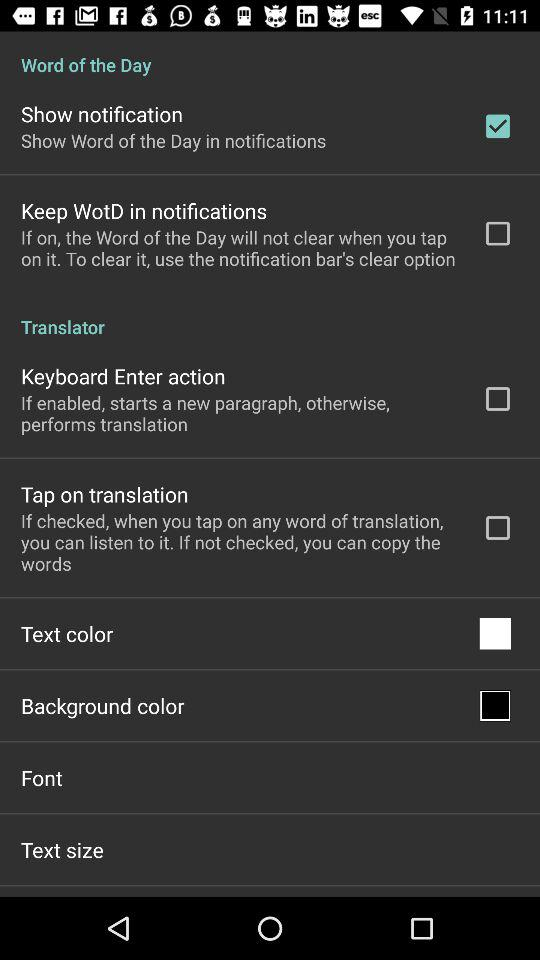How many checkbox options are there about notification?
Answer the question using a single word or phrase. 2 